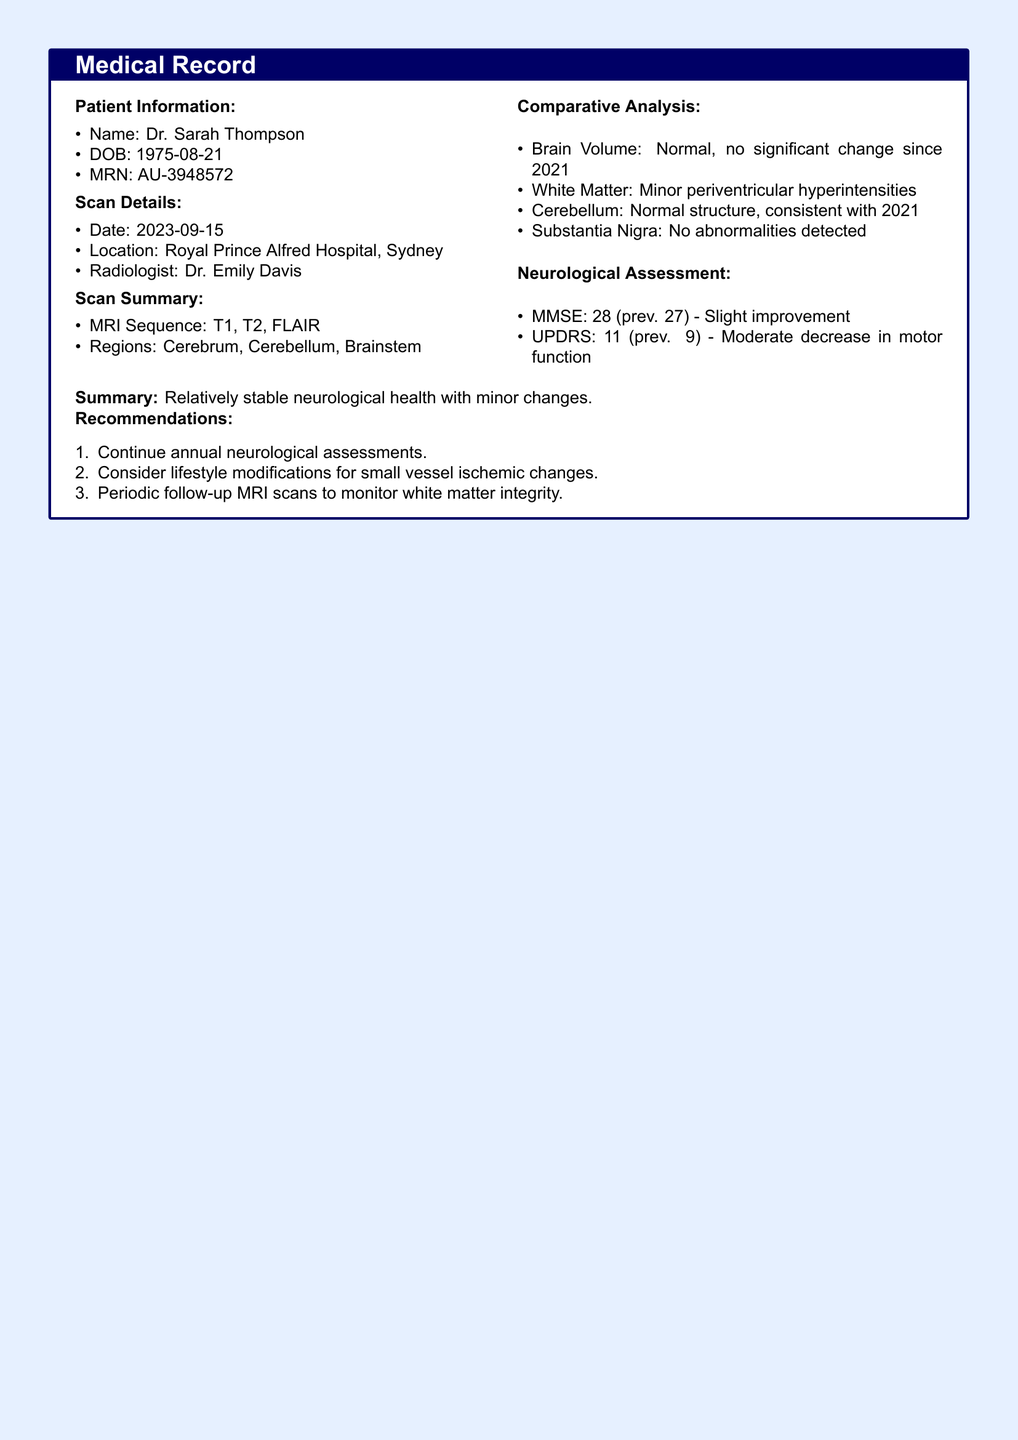what is the patient's name? The patient's name is provided in the document under Patient Information.
Answer: Dr. Sarah Thompson what is the date of the MRI scan? The date of the MRI scan is mentioned in the Scan Details section of the document.
Answer: 2023-09-15 who was the radiologist for the scan? The radiologist's name is included in the Scan Details portion of the document.
Answer: Dr. Emily Davis what was the patient's MMSE score this time? The MMSE score is listed in the Neurological Assessment section, indicating the current score.
Answer: 28 what minor finding was noted in the white matter? The document specifies changes in white matter in the Comparative Analysis section.
Answer: Minor periventricular hyperintensities how does the brain volume compare to previous scans? This information is provided in the Comparative Analysis section, indicating stability.
Answer: Normal, no significant change since 2021 what was the UPDRS score in the most recent assessment? The UPDRS score is included in the Neurological Assessment section of the document.
Answer: 11 what is the recommendation regarding lifestyle modifications? The recommendations for lifestyle changes are found in the Recommendations section.
Answer: Consider lifestyle modifications for small vessel ischemic changes which regions were examined in the MRI scan? The regions assessed during the scan are detailed in the Scan Summary.
Answer: Cerebrum, Cerebellum, Brainstem 